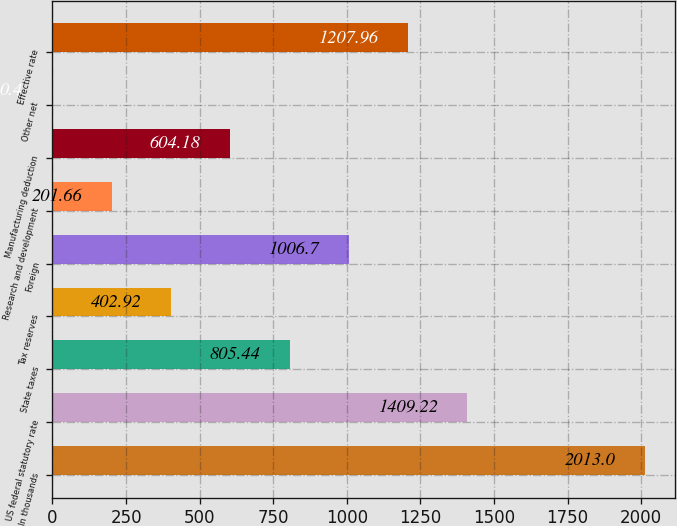<chart> <loc_0><loc_0><loc_500><loc_500><bar_chart><fcel>In thousands<fcel>US federal statutory rate<fcel>State taxes<fcel>Tax reserves<fcel>Foreign<fcel>Research and development<fcel>Manufacturing deduction<fcel>Other net<fcel>Effective rate<nl><fcel>2013<fcel>1409.22<fcel>805.44<fcel>402.92<fcel>1006.7<fcel>201.66<fcel>604.18<fcel>0.4<fcel>1207.96<nl></chart> 